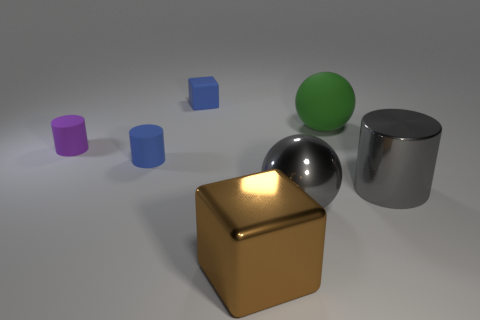What time of day or lighting conditions does the scene represent? The lighting in the scene suggests an interior setting with artificial light sources. There are soft shadows beneath the objects, indicating a diffuse light, perhaps akin to an overcast day or a room with ambient lighting. The reflections on the metallic and reflective surfaces hint that there may be a few different light sources or a single broad one illuminating the scene from above. 